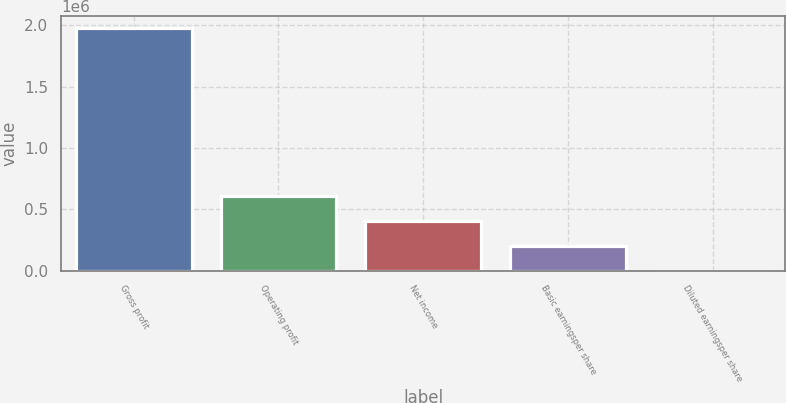Convert chart. <chart><loc_0><loc_0><loc_500><loc_500><bar_chart><fcel>Gross profit<fcel>Operating profit<fcel>Net income<fcel>Basic earningsper share<fcel>Diluted earningsper share<nl><fcel>1.97487e+06<fcel>604724<fcel>407237<fcel>197489<fcel>1.52<nl></chart> 